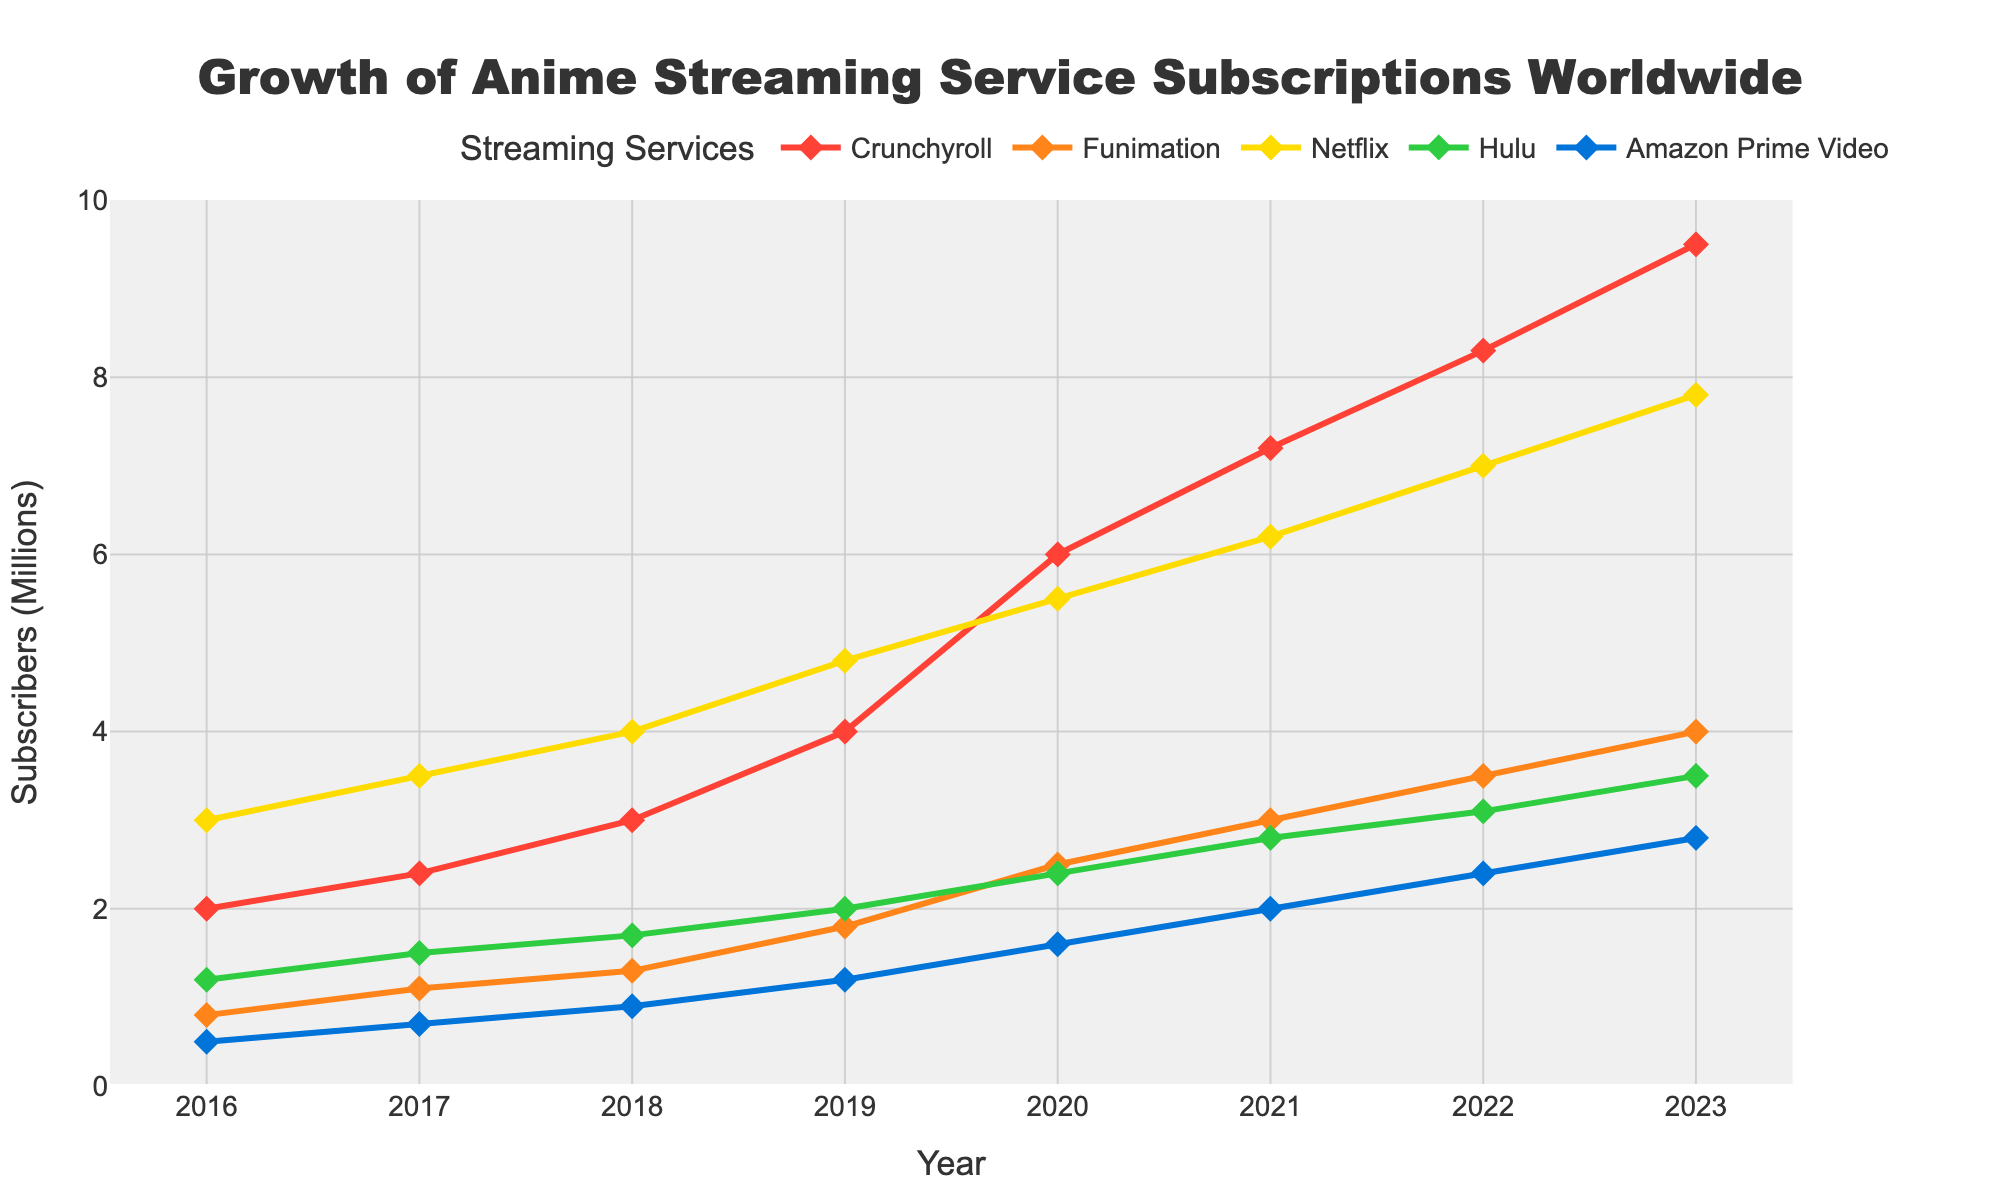What's the title of the plot? The title is displayed at the top of the figure and usually summarizes what the plot is about. The title reads, "Growth of Anime Streaming Service Subscriptions Worldwide".
Answer: Growth of Anime Streaming Service Subscriptions Worldwide What years are covered in the plot? The x-axis shows the years being analyzed. These years range from 2016 to 2023.
Answer: 2016 to 2023 Which streaming service had the highest number of subscribers in 2023? By looking at the y-values for 2023, Netflix has the highest position among all the services listed.
Answer: Netflix How many subscribers did Crunchyroll have in 2018? Locate the point for Crunchyroll on the 2018 vertical line. The y-value at this point is 3.0 million.
Answer: 3.0 million Which service showed the most significant increase in subscribers from 2016 to 2023? By comparing the slopes of the lines, Crunchyroll shows the most prominent upward trend. Its subscriber count increased from 2.0 million in 2016 to 9.5 million in 2023.
Answer: Crunchyroll What is the difference in the number of subscribers between Funimation and Hulu in 2020? Identify the values for Funimation and Hulu in 2020, which are 2.5 million and 2.4 million, respectively. Subtract Hulu's value from Funimation's value: 2.5 - 2.4 = 0.1 million.
Answer: 0.1 million What is the average number of subscribers for Amazon Prime Video over the years shown? Add the subscriber counts for Amazon Prime Video from 2016 to 2023, then divide by the number of years: (0.5 + 0.7 + 0.9 + 1.2 + 1.6 + 2.0 + 2.4 + 2.8) / 8 = 12.1 / 8 = 1.51 million.
Answer: 1.51 million In which year did Netflix reach 5 million subscribers? Trace the Netflix line to see when it first reaches or exceeds the 5 million mark. Netflix had 5.5 million subscribers in 2020, the year it reached the 5 million mark.
Answer: 2020 Which two services had the closest number of subscribers in 2021? By examining the y-values, Funimation and Hulu had 3.0 million and 2.8 million subscribers respectively in 2021. The difference is 0.2 million, which is the smallest gap among the service pairs.
Answer: Funimation and Hulu Is there any instance where the number of subscribers decreased for any service over the years displayed? None of the lines for the services show a downward slope at any point on the plot, indicating that subscriber counts have not decreased for any of the services over the years.
Answer: No 